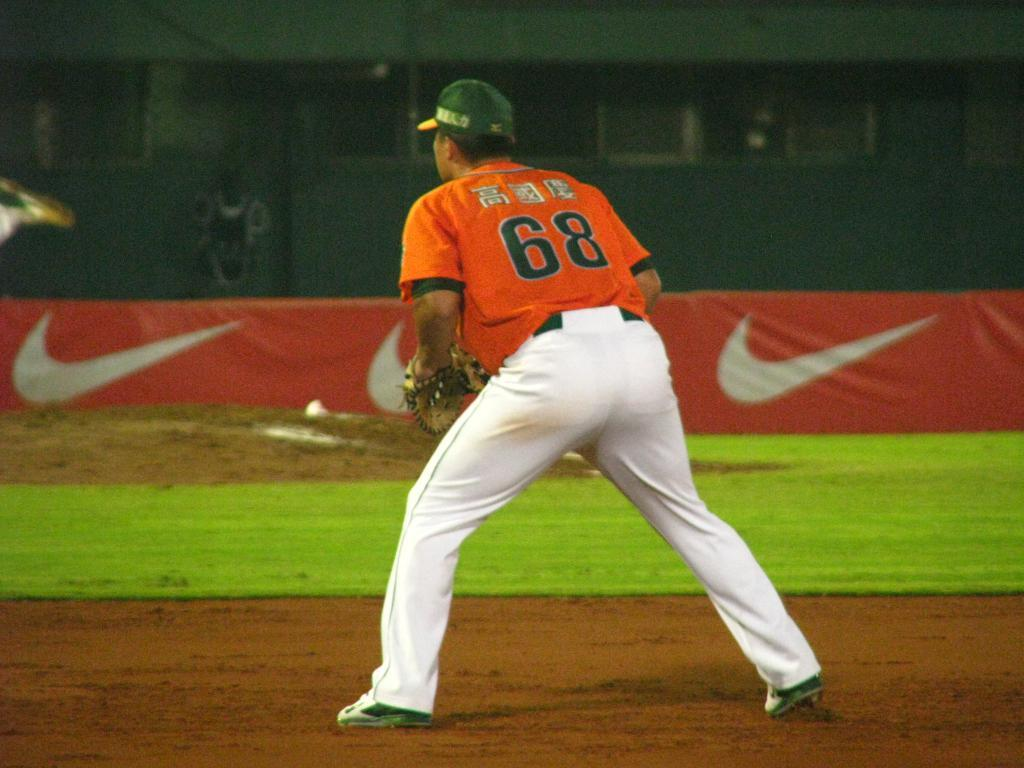Provide a one-sentence caption for the provided image. Player number 68 is standing out on the field ready to catch the ball. 